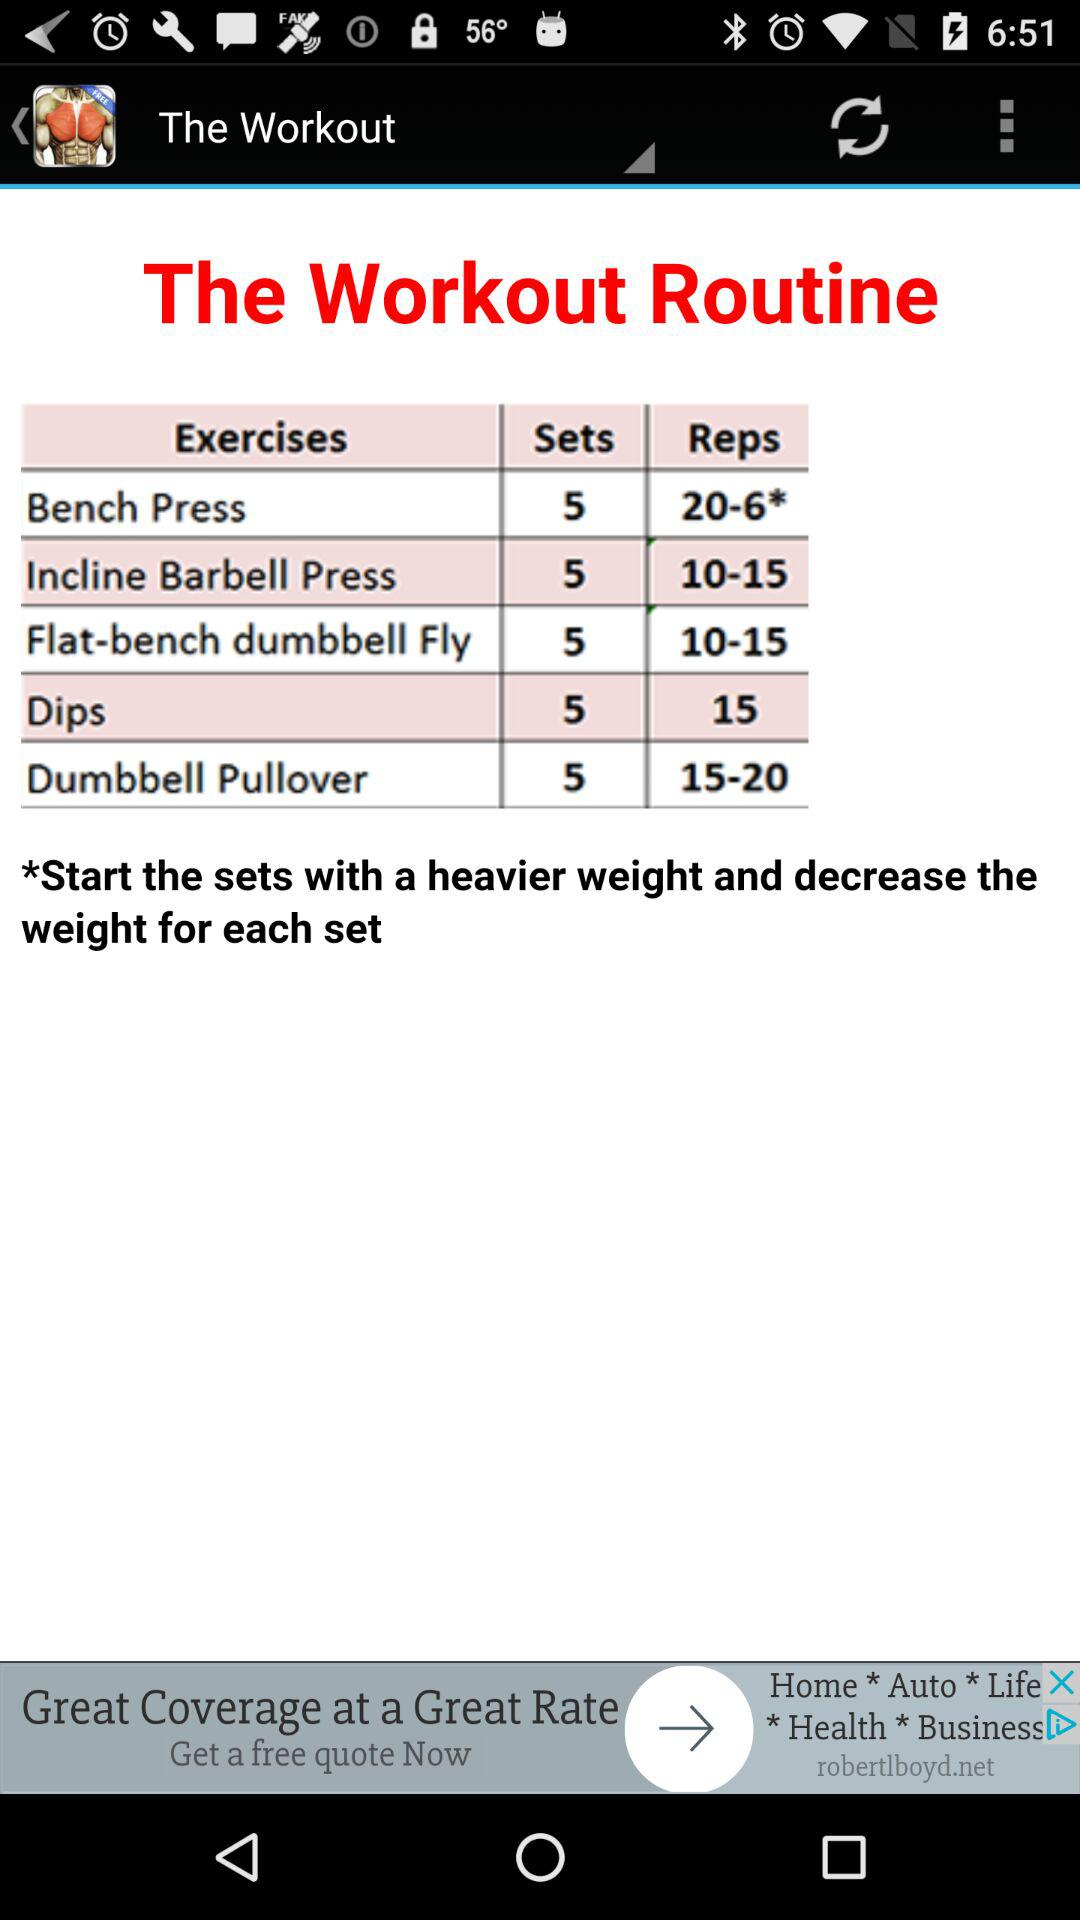How many reps do you do for the Dumbbell Pullover?
Answer the question using a single word or phrase. 15-20 